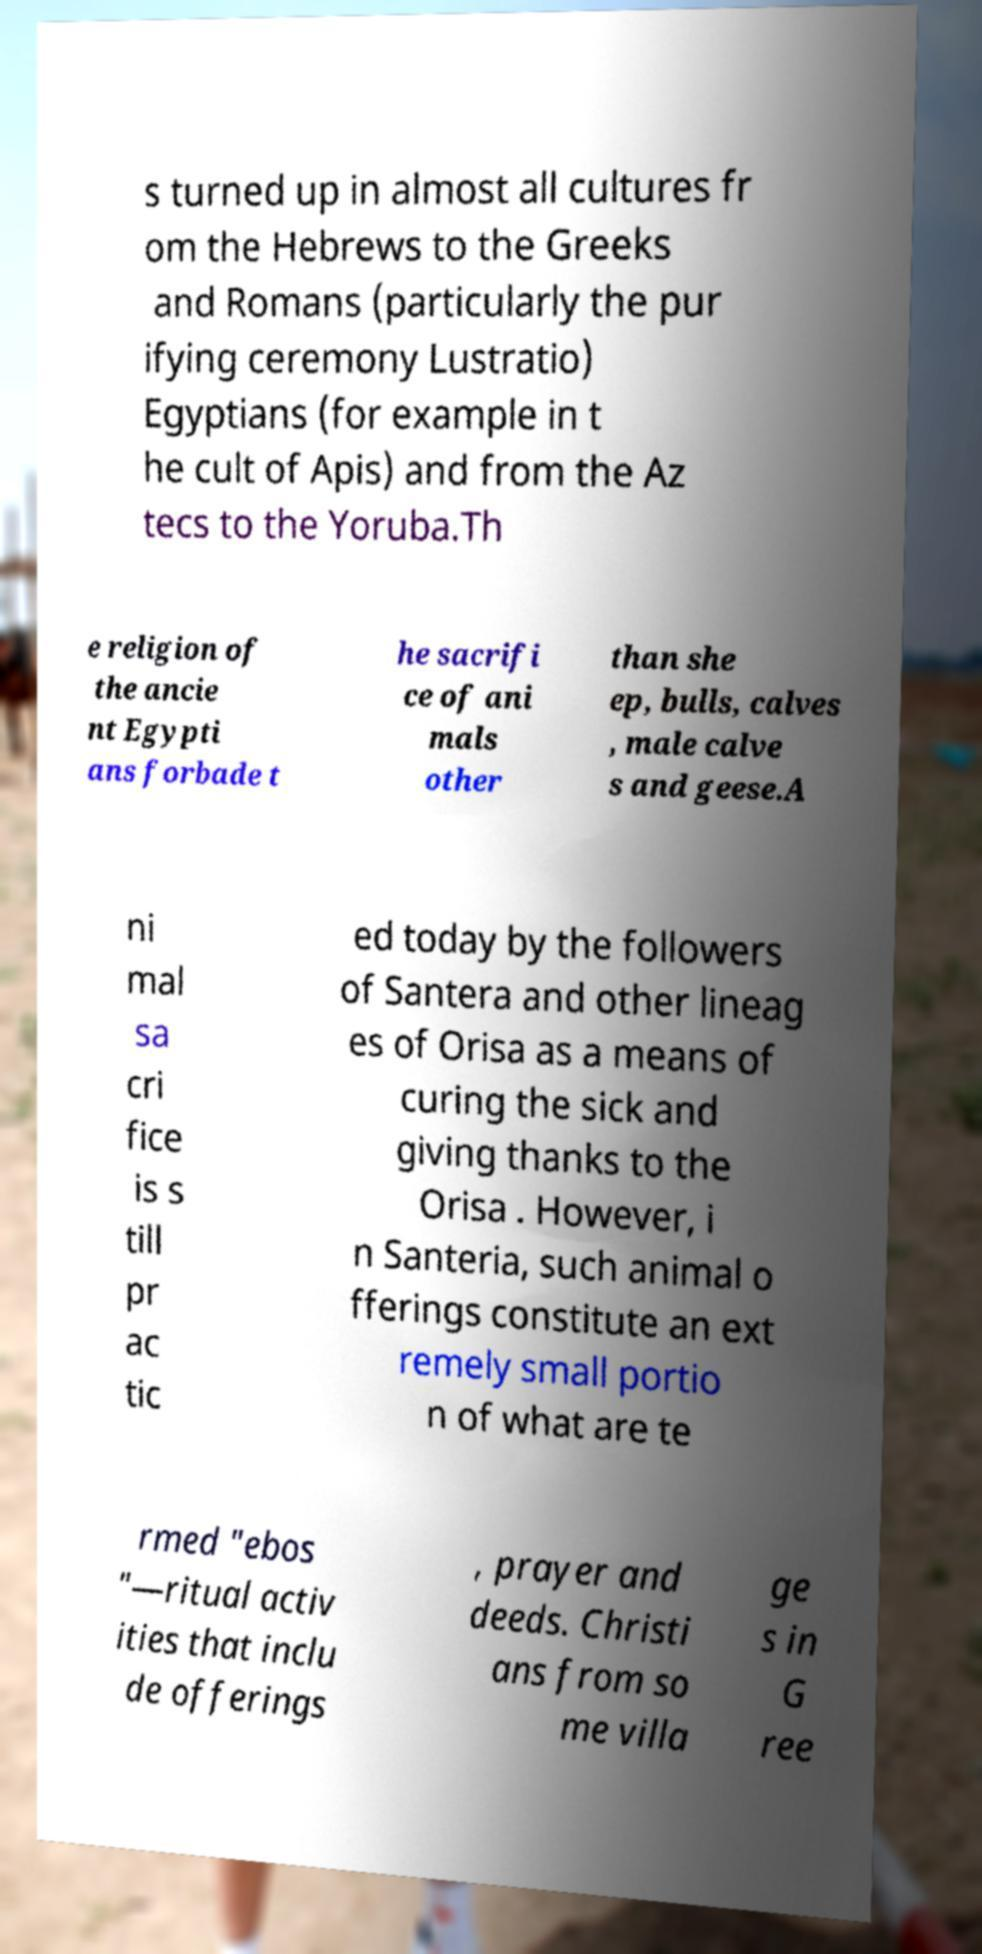Can you accurately transcribe the text from the provided image for me? s turned up in almost all cultures fr om the Hebrews to the Greeks and Romans (particularly the pur ifying ceremony Lustratio) Egyptians (for example in t he cult of Apis) and from the Az tecs to the Yoruba.Th e religion of the ancie nt Egypti ans forbade t he sacrifi ce of ani mals other than she ep, bulls, calves , male calve s and geese.A ni mal sa cri fice is s till pr ac tic ed today by the followers of Santera and other lineag es of Orisa as a means of curing the sick and giving thanks to the Orisa . However, i n Santeria, such animal o fferings constitute an ext remely small portio n of what are te rmed "ebos "—ritual activ ities that inclu de offerings , prayer and deeds. Christi ans from so me villa ge s in G ree 